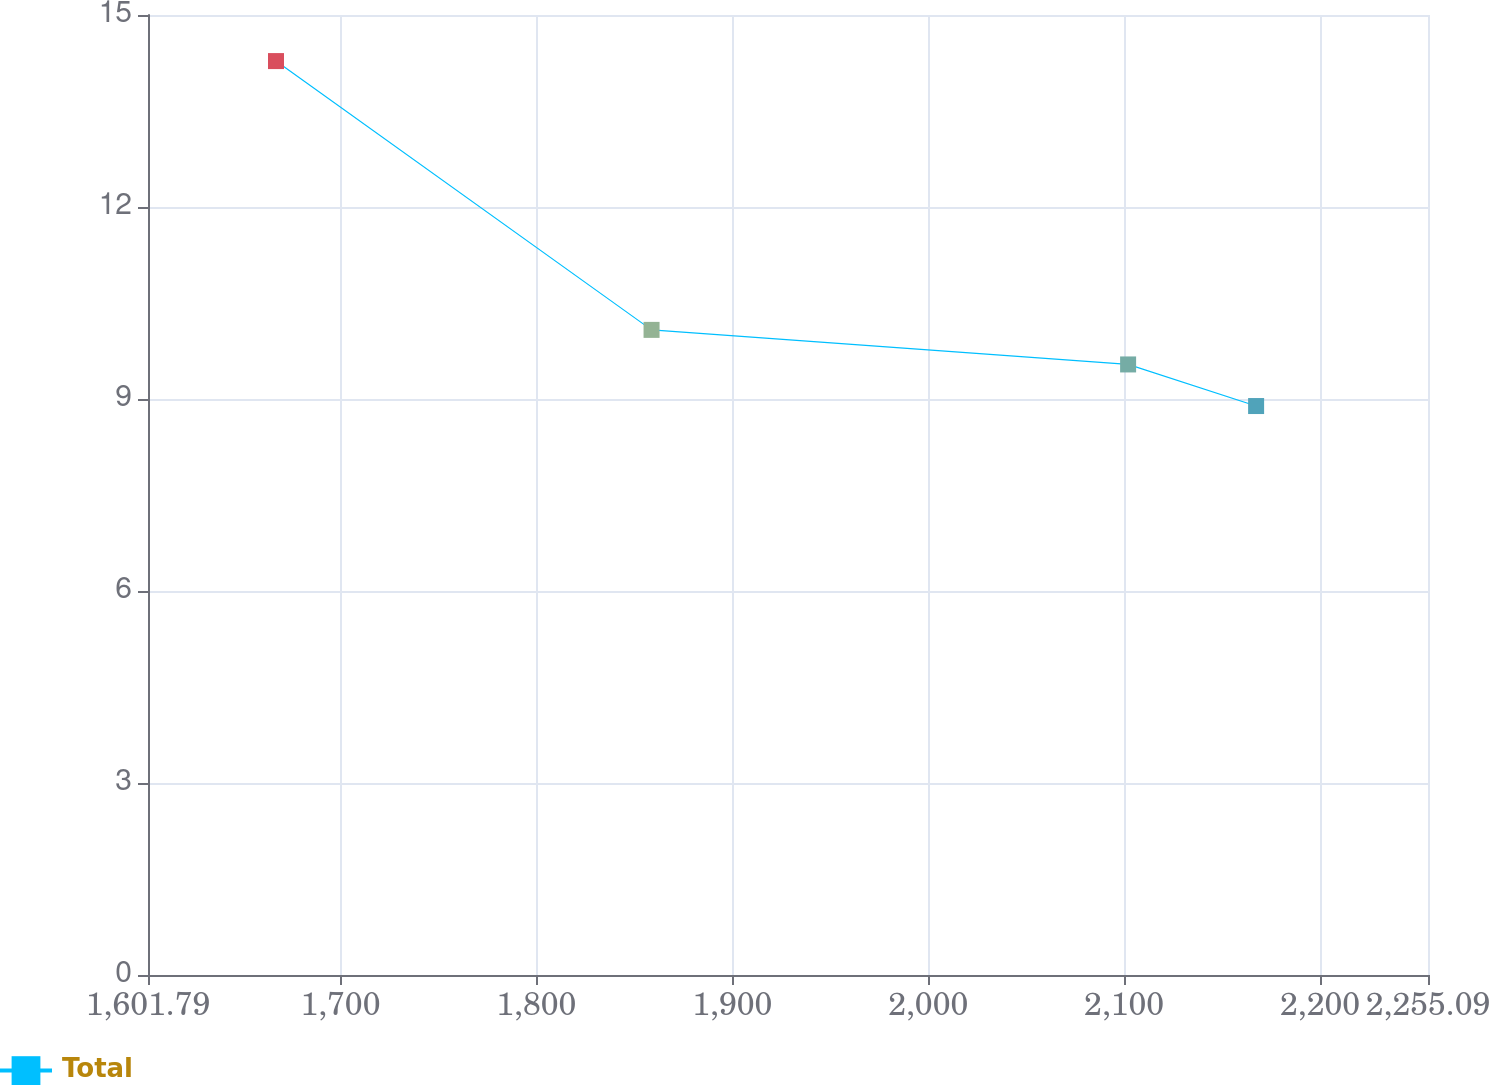<chart> <loc_0><loc_0><loc_500><loc_500><line_chart><ecel><fcel>Total<nl><fcel>1667.12<fcel>14.28<nl><fcel>1858.8<fcel>10.08<nl><fcel>2102.03<fcel>9.54<nl><fcel>2167.36<fcel>8.89<nl><fcel>2320.42<fcel>11.09<nl></chart> 